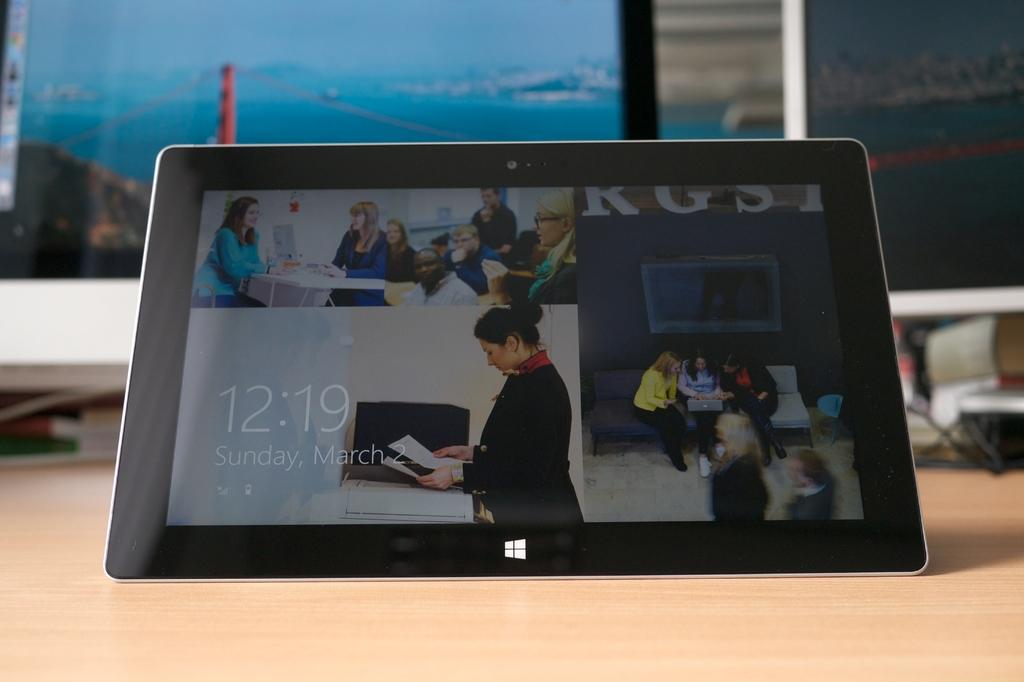What is the main object in the center of the image? There is a tablet in the center of the image. Where is the tablet placed? The tablet is placed on a table. What can be seen in the background of the image? There are books and monitors in the background of the image. How many divisions can be seen in the tablet's screen in the image? There is no information about divisions on the tablet's screen in the image. Can you see any cats in the image? There are no cats present in the image. 